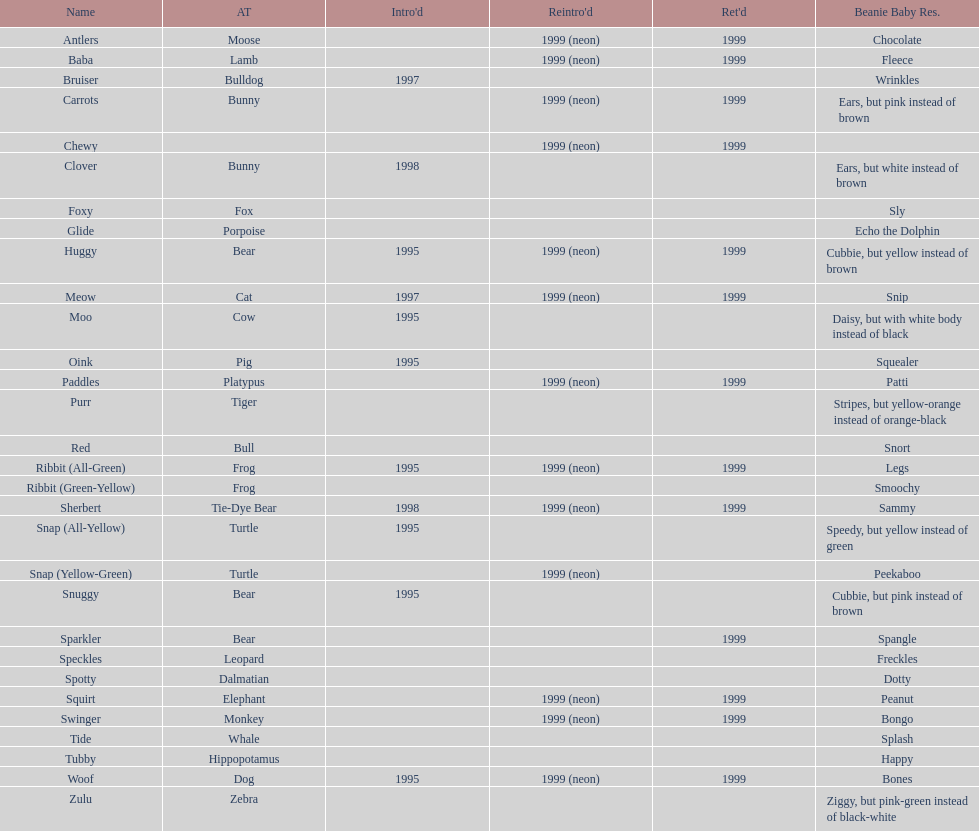How many monkey pillow pals existed? 1. 